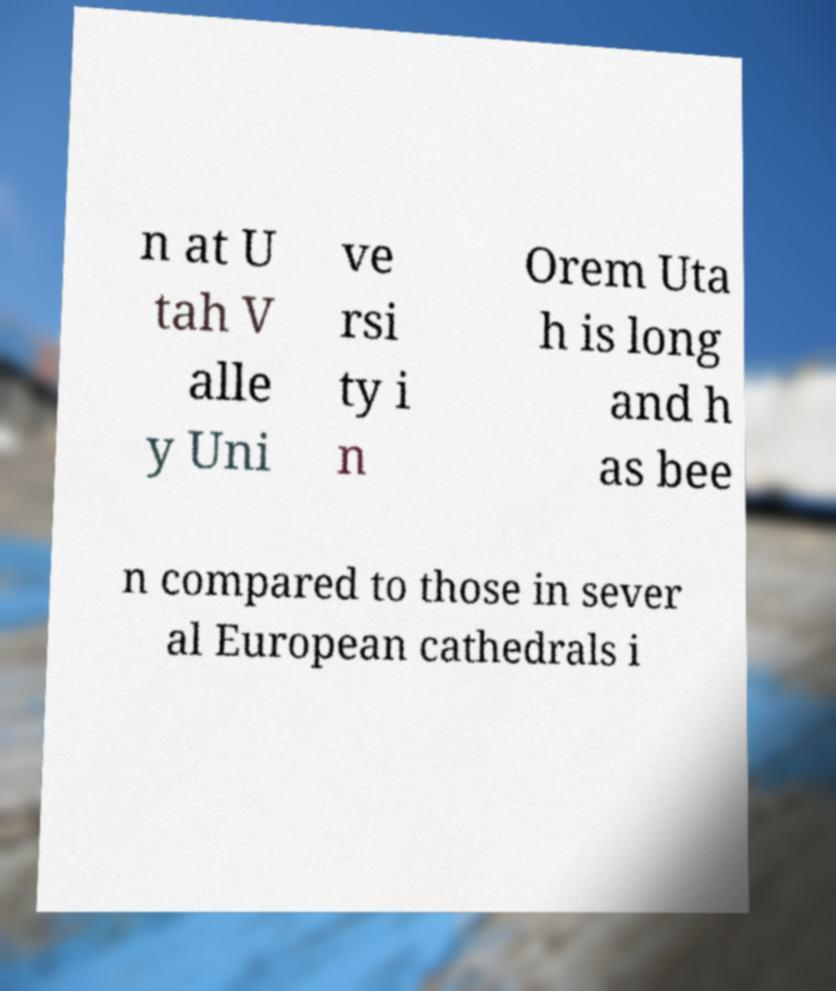Can you read and provide the text displayed in the image?This photo seems to have some interesting text. Can you extract and type it out for me? n at U tah V alle y Uni ve rsi ty i n Orem Uta h is long and h as bee n compared to those in sever al European cathedrals i 